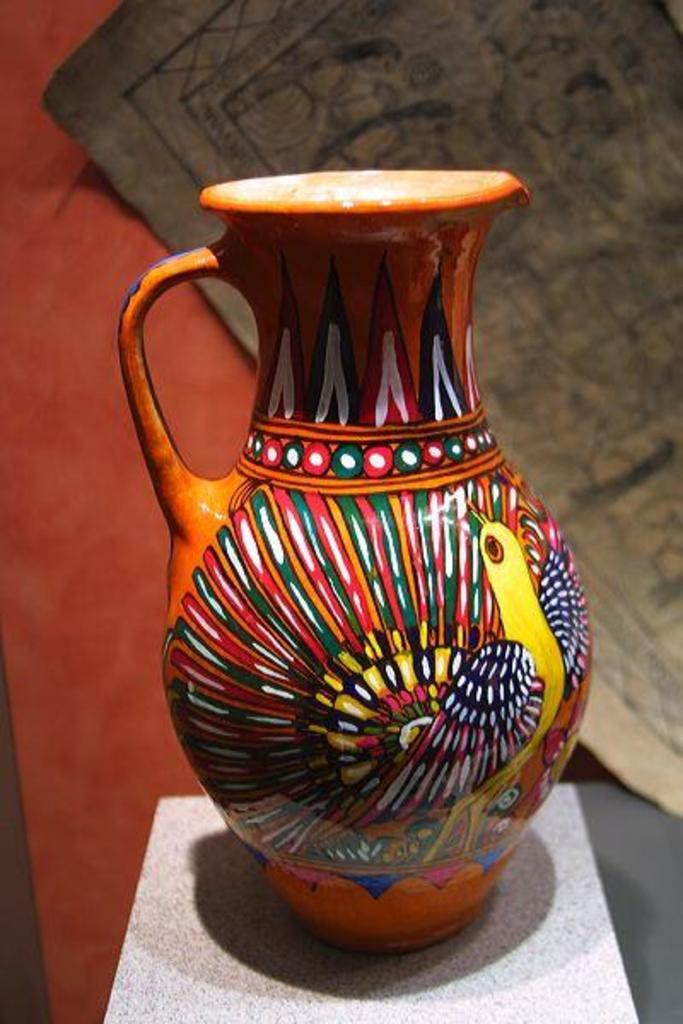What is the main object in the image? There is a jug in the image. What is unique about the jug? The jug has a painting on it. What other object is placed on a stool? There is a mug placed on a stool. What can be seen in the background of the image? There is a poster and an orange color sheet in the background. Can you tell me how many geese are playing on the playground in the image? There is no playground or geese present in the image. What color is the color sheet in the image? The color sheet in the image is orange. 